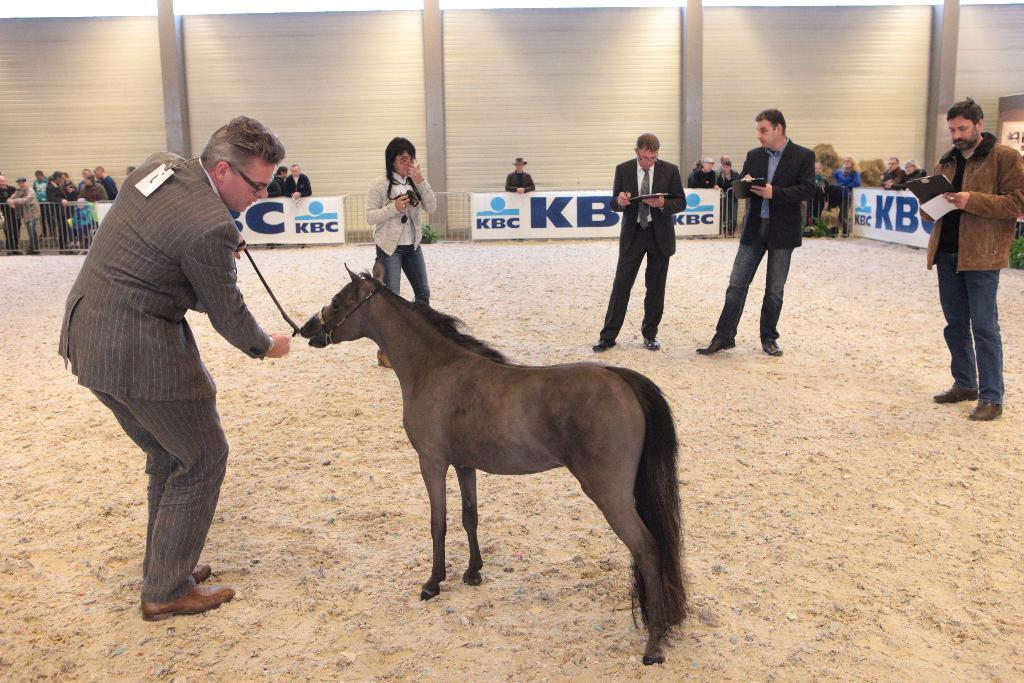What can be seen in the image involving living beings? There are people standing in the image, and there is a horse in the image. What else is present in the image besides the people and the horse? There is a banner in the image. How many hands can be seen holding the horse's reins in the image? There is no information about hands or holding the horse's reins in the image, as the facts only mention the presence of people and a horse. 